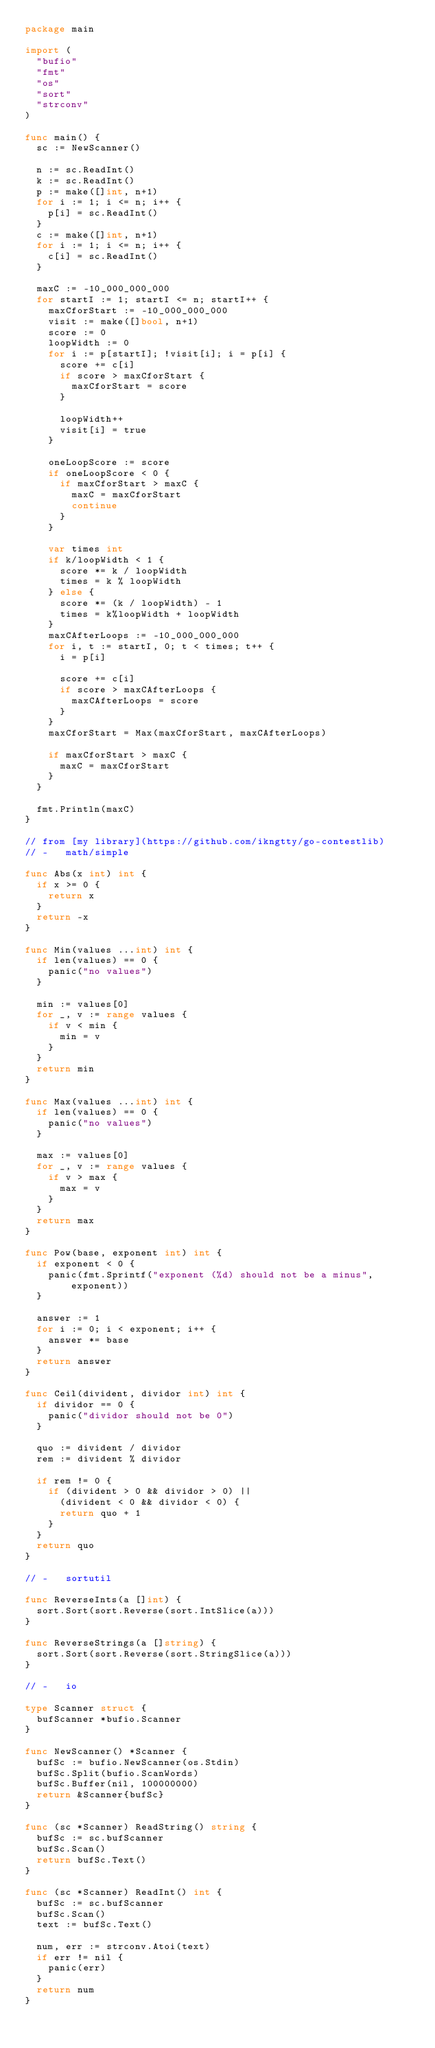Convert code to text. <code><loc_0><loc_0><loc_500><loc_500><_Go_>package main

import (
	"bufio"
	"fmt"
	"os"
	"sort"
	"strconv"
)

func main() {
	sc := NewScanner()

	n := sc.ReadInt()
	k := sc.ReadInt()
	p := make([]int, n+1)
	for i := 1; i <= n; i++ {
		p[i] = sc.ReadInt()
	}
	c := make([]int, n+1)
	for i := 1; i <= n; i++ {
		c[i] = sc.ReadInt()
	}

	maxC := -10_000_000_000
	for startI := 1; startI <= n; startI++ {
		maxCforStart := -10_000_000_000
		visit := make([]bool, n+1)
		score := 0
		loopWidth := 0
		for i := p[startI]; !visit[i]; i = p[i] {
			score += c[i]
			if score > maxCforStart {
				maxCforStart = score
			}

			loopWidth++
			visit[i] = true
		}

		oneLoopScore := score
		if oneLoopScore < 0 {
			if maxCforStart > maxC {
				maxC = maxCforStart
				continue
			}
		}

		var times int
		if k/loopWidth < 1 {
			score *= k / loopWidth
			times = k % loopWidth
		} else {
			score *= (k / loopWidth) - 1
			times = k%loopWidth + loopWidth
		}
		maxCAfterLoops := -10_000_000_000
		for i, t := startI, 0; t < times; t++ {
			i = p[i]

			score += c[i]
			if score > maxCAfterLoops {
				maxCAfterLoops = score
			}
		}
		maxCforStart = Max(maxCforStart, maxCAfterLoops)

		if maxCforStart > maxC {
			maxC = maxCforStart
		}
	}

	fmt.Println(maxC)
}

// from [my library](https://github.com/ikngtty/go-contestlib)
// -   math/simple

func Abs(x int) int {
	if x >= 0 {
		return x
	}
	return -x
}

func Min(values ...int) int {
	if len(values) == 0 {
		panic("no values")
	}

	min := values[0]
	for _, v := range values {
		if v < min {
			min = v
		}
	}
	return min
}

func Max(values ...int) int {
	if len(values) == 0 {
		panic("no values")
	}

	max := values[0]
	for _, v := range values {
		if v > max {
			max = v
		}
	}
	return max
}

func Pow(base, exponent int) int {
	if exponent < 0 {
		panic(fmt.Sprintf("exponent (%d) should not be a minus", exponent))
	}

	answer := 1
	for i := 0; i < exponent; i++ {
		answer *= base
	}
	return answer
}

func Ceil(divident, dividor int) int {
	if dividor == 0 {
		panic("dividor should not be 0")
	}

	quo := divident / dividor
	rem := divident % dividor

	if rem != 0 {
		if (divident > 0 && dividor > 0) ||
			(divident < 0 && dividor < 0) {
			return quo + 1
		}
	}
	return quo
}

// -   sortutil

func ReverseInts(a []int) {
	sort.Sort(sort.Reverse(sort.IntSlice(a)))
}

func ReverseStrings(a []string) {
	sort.Sort(sort.Reverse(sort.StringSlice(a)))
}

// -   io

type Scanner struct {
	bufScanner *bufio.Scanner
}

func NewScanner() *Scanner {
	bufSc := bufio.NewScanner(os.Stdin)
	bufSc.Split(bufio.ScanWords)
	bufSc.Buffer(nil, 100000000)
	return &Scanner{bufSc}
}

func (sc *Scanner) ReadString() string {
	bufSc := sc.bufScanner
	bufSc.Scan()
	return bufSc.Text()
}

func (sc *Scanner) ReadInt() int {
	bufSc := sc.bufScanner
	bufSc.Scan()
	text := bufSc.Text()

	num, err := strconv.Atoi(text)
	if err != nil {
		panic(err)
	}
	return num
}
</code> 